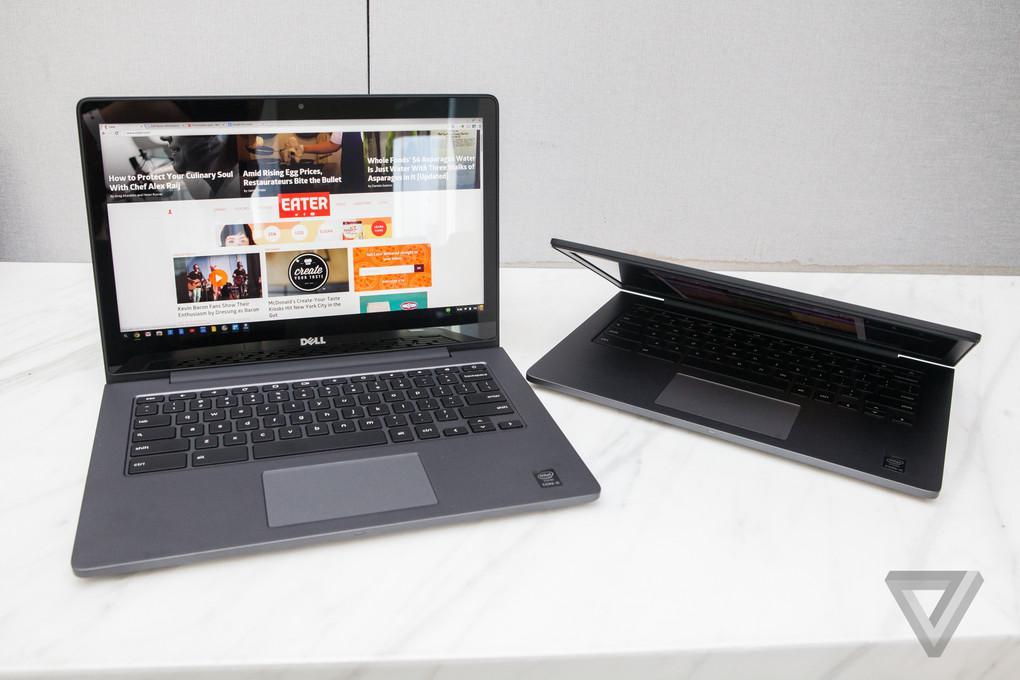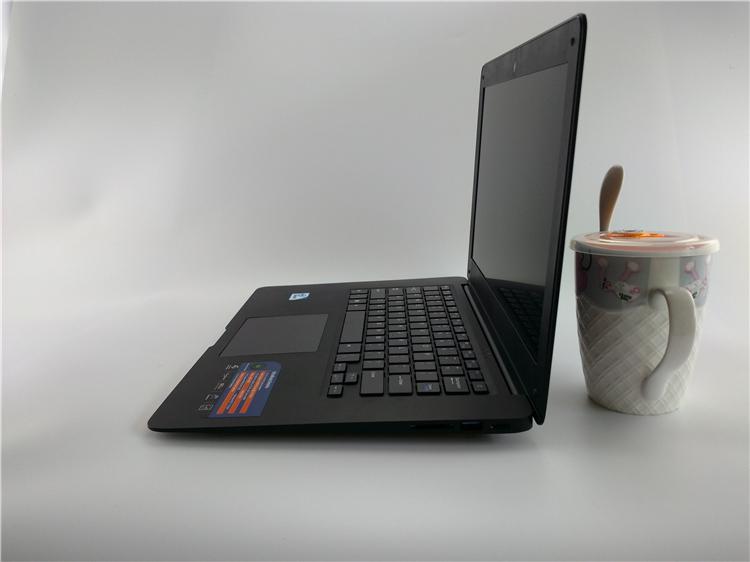The first image is the image on the left, the second image is the image on the right. Considering the images on both sides, is "There are three computers" valid? Answer yes or no. Yes. The first image is the image on the left, the second image is the image on the right. For the images shown, is this caption "There are two laptops in one of the images." true? Answer yes or no. Yes. 